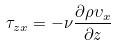Convert formula to latex. <formula><loc_0><loc_0><loc_500><loc_500>\tau _ { z x } = - \nu \frac { \partial \rho \upsilon _ { x } } { \partial z }</formula> 